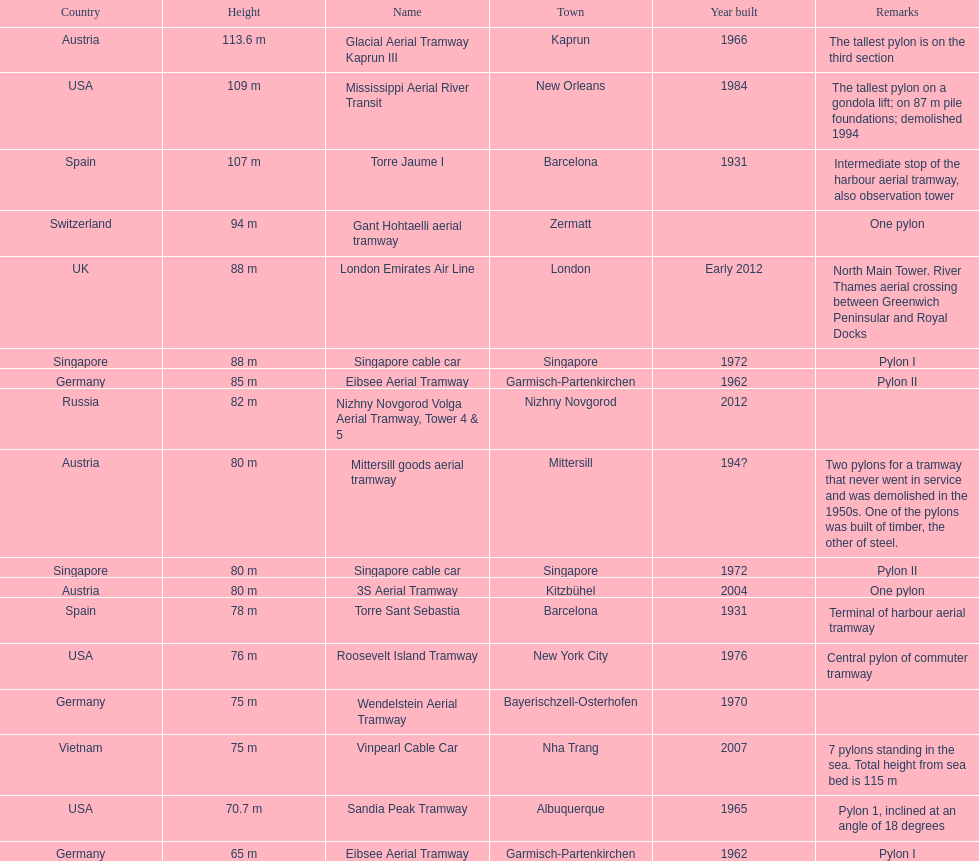What is the total number of pylons listed? 17. 